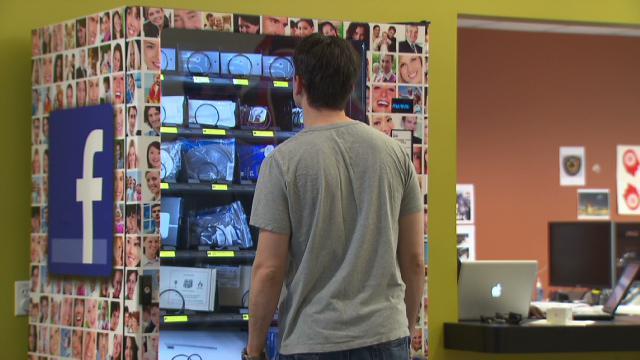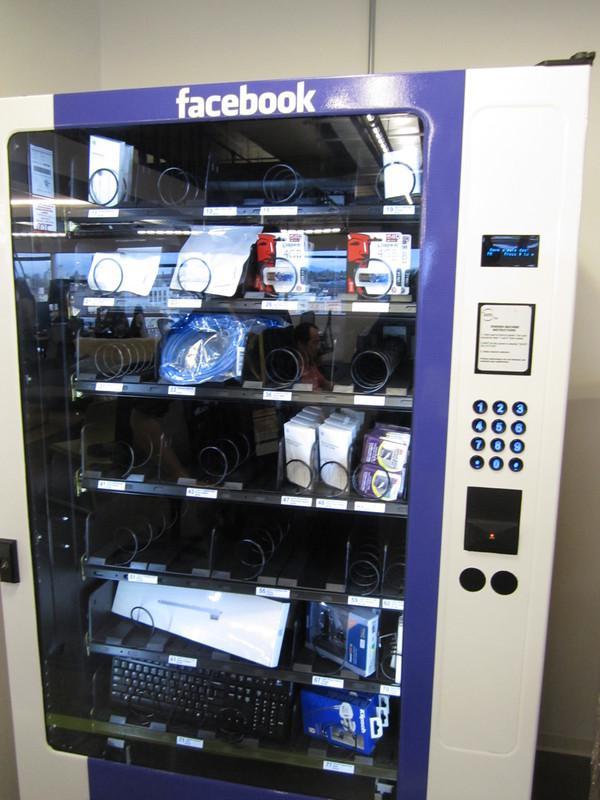The first image is the image on the left, the second image is the image on the right. For the images displayed, is the sentence "Two people are shown at vending machines." factually correct? Answer yes or no. No. The first image is the image on the left, the second image is the image on the right. Considering the images on both sides, is "There is a woman touching a vending machine." valid? Answer yes or no. No. 